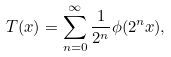<formula> <loc_0><loc_0><loc_500><loc_500>T ( x ) = \sum _ { n = 0 } ^ { \infty } \frac { 1 } { 2 ^ { n } } \phi ( 2 ^ { n } x ) ,</formula> 